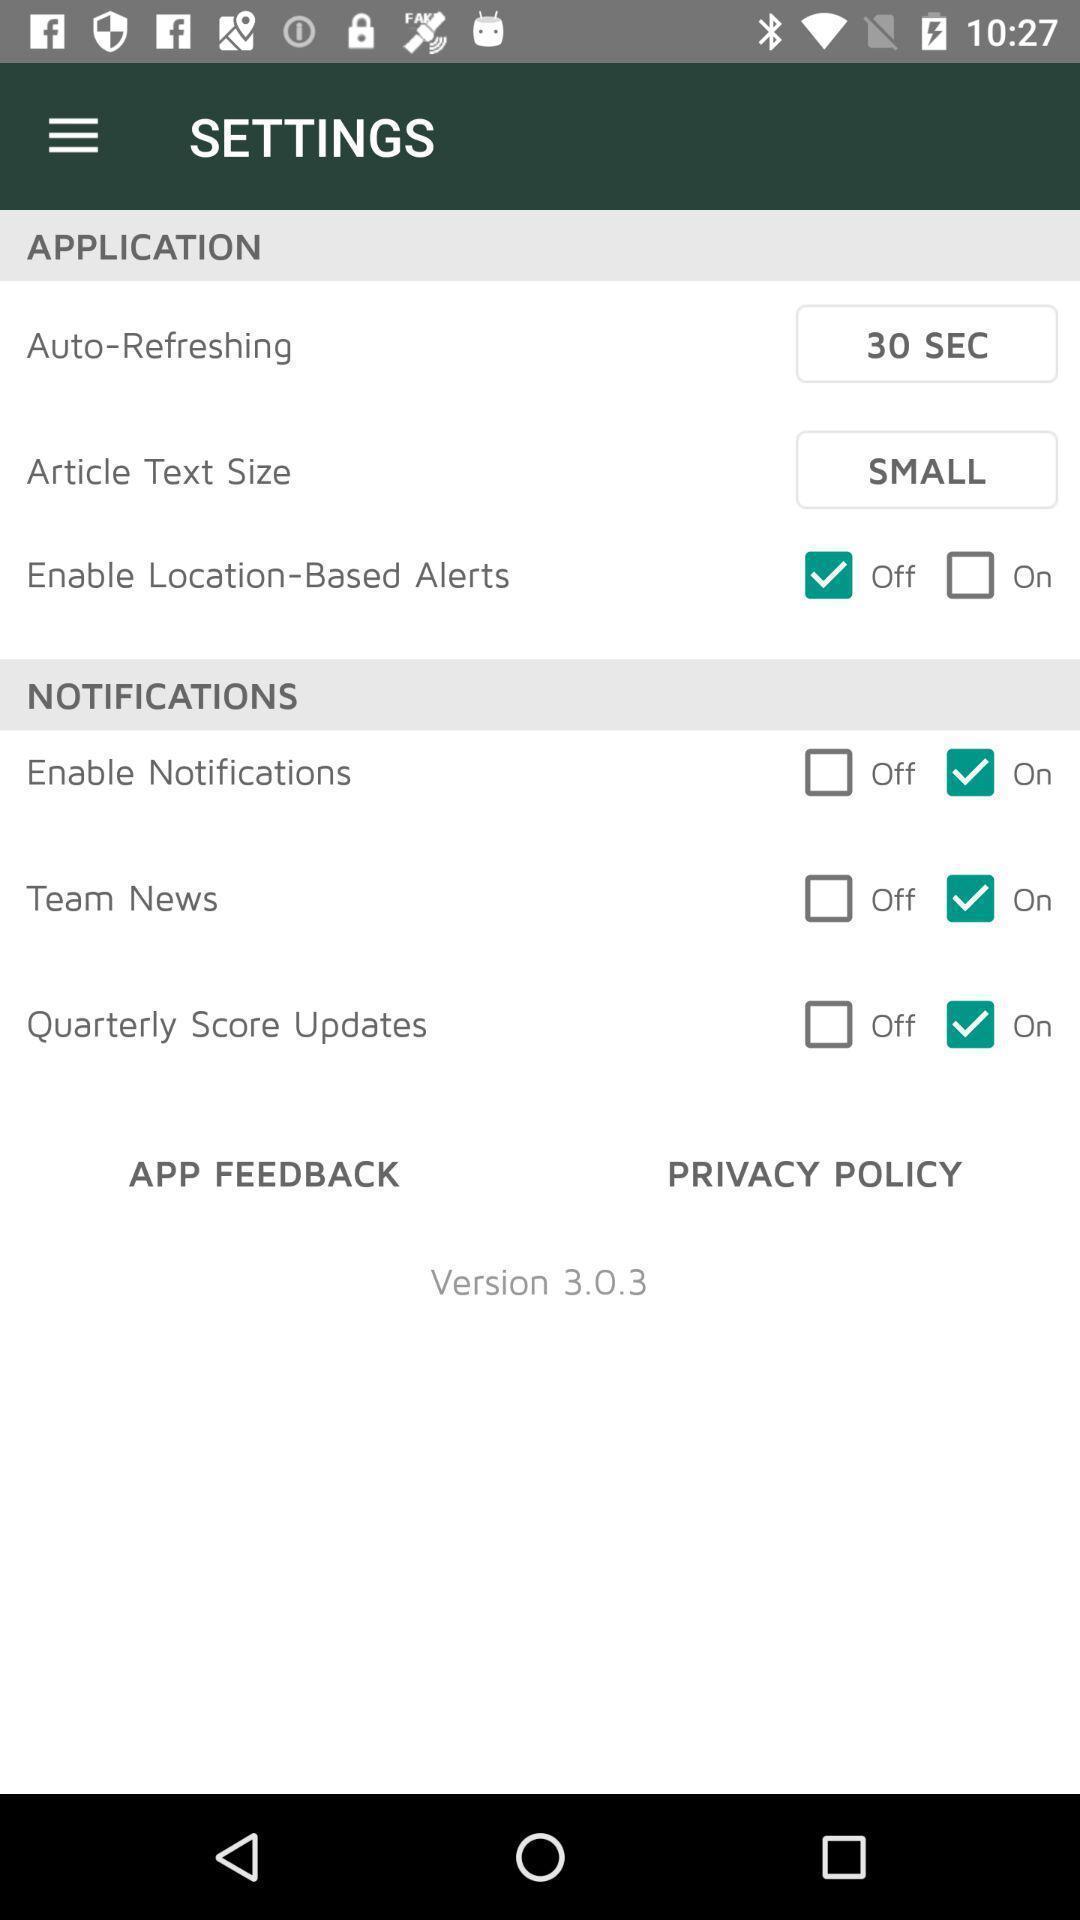Describe the content in this image. Screen displaying the settings page. 